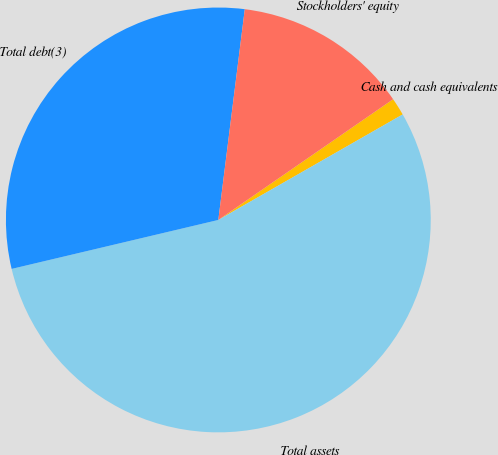Convert chart. <chart><loc_0><loc_0><loc_500><loc_500><pie_chart><fcel>Cash and cash equivalents<fcel>Total assets<fcel>Total debt(3)<fcel>Stockholders' equity<nl><fcel>1.35%<fcel>54.57%<fcel>30.69%<fcel>13.39%<nl></chart> 